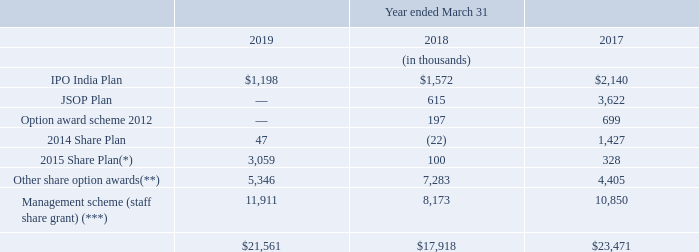28 SHARE BASED COMPENSATION PLANS
The compensation cost recognised with respect to all outstanding plans and by grant of shares, which are all equity settled instruments, is as follows:
(*) includes of 1,305,399 options granted towards Share Plan 2015 during twelve months ended March 31, 2019 at an average exercise price of $14.86 per share and average grant date fair value $2.6 per share.
(**) includes Restricted Share Unit (RSU) and Other share option plans. In respect of 211,567 units/options granted towards RSU during twelve months ended March 31, 2019, grant date fair value approximates intrinsic value $10.48 per share. (**) includes Restricted Share Unit (RSU) and Other share option plans. In respect of 211,567 units/options granted towards RSU during twelve months ended March 31, 2019, grant date fair value approximates intrinsic value $10.48 per share.
(***) includes 1,400,000 shares granted twelve months ended March 31, 2019 to management personnel at grant date fair value $10.08 per share.
Joint Stock Ownership Plan (JSOP)
In April 2012, the Company established a controlled trust called the Eros International Plc Employee Benefit Trust (“JSOP Trust”). The JSOP Trust purchased 2,000,164 shares of the Company out of funds borrowed from the Company and repayable on demand. The Company’s Board, Nomination and Remuneration Committee recommends to the JSOP Trust certain employees, officers and key management personnel, to whom the JSOP Trust will be required to grant shares from its holdings at nominal price. Such shares are then held by the JSOP Trust and the scheme is referred to as the “JSOP Plan.” The shares held by the JSOP Trust are reported as a reduction in stockholders’ equity and termed as ‘JSOP reserves’.
What is the amount of options granted towards Share Plans in 2019? 1,305,399. What are the fiscal years included in the table? 2019, 2018, 2017. What is the IPO India Plan value in 2019?
Answer scale should be: thousand. $1,198. How many fiscal years had  IPO India Plan above $2,000 thousand? 2017
Answer: 1. Which fiscal year had the greatest total compensation cost? 23,471>21,561>17,918
Answer: 2017. Which fiscal year had the lowest Management scheme (staff share grant) compensation costs? 8,173<10,850<11,911
Answer: 2018. 